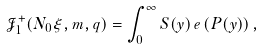<formula> <loc_0><loc_0><loc_500><loc_500>\mathcal { J } ^ { + } _ { 1 } ( N _ { 0 } \xi , m , q ) = \int _ { 0 } ^ { \infty } S ( y ) \, e \left ( P ( y ) \right ) ,</formula> 